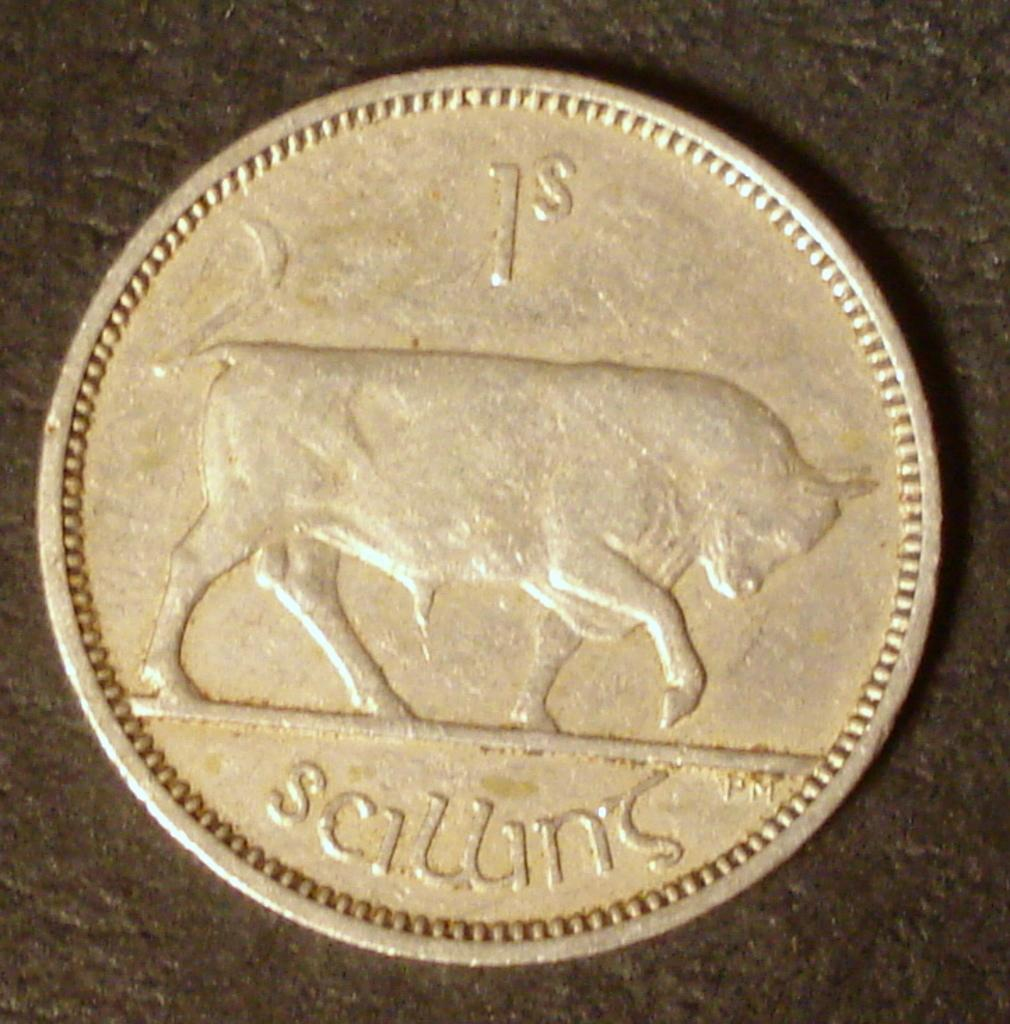<image>
Present a compact description of the photo's key features. the number 1 is on a coin with a bull 